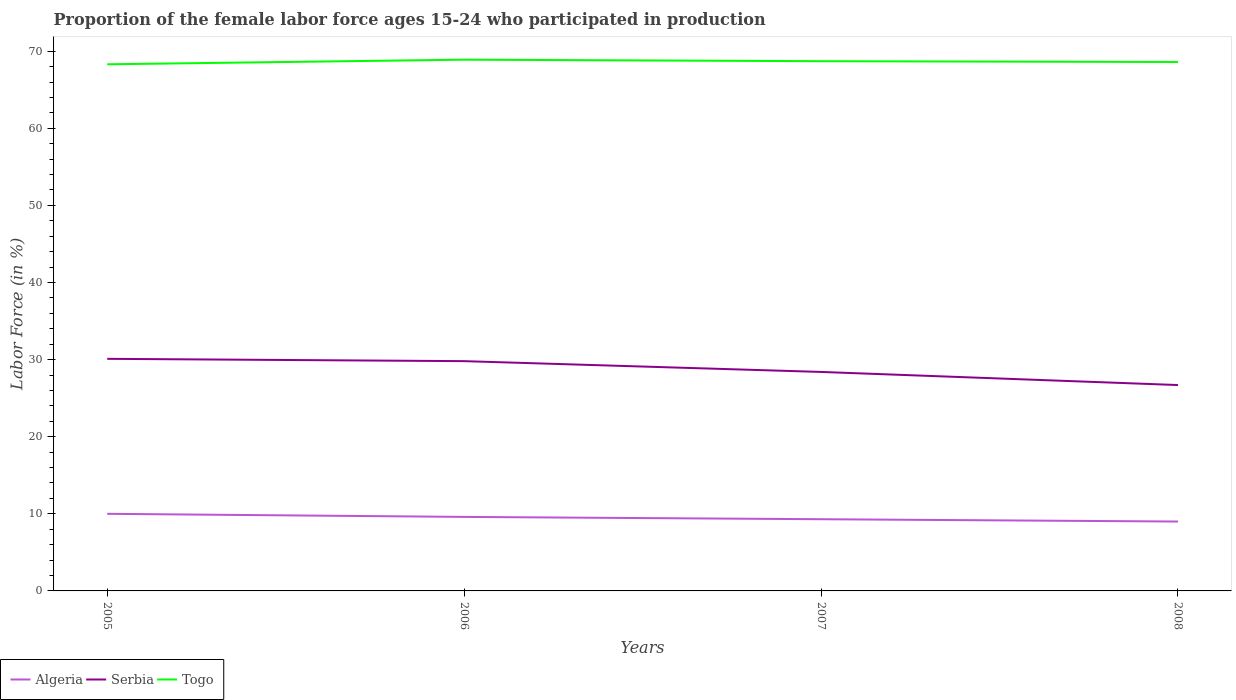How many different coloured lines are there?
Your response must be concise. 3. Does the line corresponding to Serbia intersect with the line corresponding to Togo?
Ensure brevity in your answer.  No. Is the number of lines equal to the number of legend labels?
Make the answer very short. Yes. Across all years, what is the maximum proportion of the female labor force who participated in production in Serbia?
Provide a succinct answer. 26.7. In which year was the proportion of the female labor force who participated in production in Serbia maximum?
Make the answer very short. 2008. What is the total proportion of the female labor force who participated in production in Serbia in the graph?
Your answer should be very brief. 0.3. What is the difference between the highest and the second highest proportion of the female labor force who participated in production in Togo?
Your answer should be compact. 0.6. How many years are there in the graph?
Keep it short and to the point. 4. What is the difference between two consecutive major ticks on the Y-axis?
Your response must be concise. 10. Are the values on the major ticks of Y-axis written in scientific E-notation?
Your answer should be compact. No. Where does the legend appear in the graph?
Your response must be concise. Bottom left. How many legend labels are there?
Your answer should be compact. 3. What is the title of the graph?
Provide a succinct answer. Proportion of the female labor force ages 15-24 who participated in production. Does "Switzerland" appear as one of the legend labels in the graph?
Ensure brevity in your answer.  No. What is the label or title of the X-axis?
Your answer should be very brief. Years. What is the Labor Force (in %) in Algeria in 2005?
Provide a short and direct response. 10. What is the Labor Force (in %) in Serbia in 2005?
Provide a short and direct response. 30.1. What is the Labor Force (in %) in Togo in 2005?
Ensure brevity in your answer.  68.3. What is the Labor Force (in %) of Algeria in 2006?
Give a very brief answer. 9.6. What is the Labor Force (in %) in Serbia in 2006?
Your response must be concise. 29.8. What is the Labor Force (in %) of Togo in 2006?
Provide a succinct answer. 68.9. What is the Labor Force (in %) of Algeria in 2007?
Keep it short and to the point. 9.3. What is the Labor Force (in %) in Serbia in 2007?
Offer a terse response. 28.4. What is the Labor Force (in %) of Togo in 2007?
Your answer should be compact. 68.7. What is the Labor Force (in %) of Serbia in 2008?
Your response must be concise. 26.7. What is the Labor Force (in %) in Togo in 2008?
Your answer should be very brief. 68.6. Across all years, what is the maximum Labor Force (in %) of Algeria?
Ensure brevity in your answer.  10. Across all years, what is the maximum Labor Force (in %) of Serbia?
Your response must be concise. 30.1. Across all years, what is the maximum Labor Force (in %) of Togo?
Ensure brevity in your answer.  68.9. Across all years, what is the minimum Labor Force (in %) of Serbia?
Provide a short and direct response. 26.7. Across all years, what is the minimum Labor Force (in %) in Togo?
Your answer should be very brief. 68.3. What is the total Labor Force (in %) of Algeria in the graph?
Your answer should be compact. 37.9. What is the total Labor Force (in %) of Serbia in the graph?
Your answer should be very brief. 115. What is the total Labor Force (in %) of Togo in the graph?
Offer a terse response. 274.5. What is the difference between the Labor Force (in %) of Togo in 2005 and that in 2006?
Make the answer very short. -0.6. What is the difference between the Labor Force (in %) in Serbia in 2005 and that in 2008?
Your answer should be very brief. 3.4. What is the difference between the Labor Force (in %) of Algeria in 2006 and that in 2007?
Provide a succinct answer. 0.3. What is the difference between the Labor Force (in %) in Togo in 2006 and that in 2007?
Your answer should be very brief. 0.2. What is the difference between the Labor Force (in %) of Serbia in 2006 and that in 2008?
Ensure brevity in your answer.  3.1. What is the difference between the Labor Force (in %) of Togo in 2006 and that in 2008?
Ensure brevity in your answer.  0.3. What is the difference between the Labor Force (in %) in Algeria in 2005 and the Labor Force (in %) in Serbia in 2006?
Your response must be concise. -19.8. What is the difference between the Labor Force (in %) of Algeria in 2005 and the Labor Force (in %) of Togo in 2006?
Offer a terse response. -58.9. What is the difference between the Labor Force (in %) in Serbia in 2005 and the Labor Force (in %) in Togo in 2006?
Offer a terse response. -38.8. What is the difference between the Labor Force (in %) of Algeria in 2005 and the Labor Force (in %) of Serbia in 2007?
Offer a terse response. -18.4. What is the difference between the Labor Force (in %) in Algeria in 2005 and the Labor Force (in %) in Togo in 2007?
Offer a terse response. -58.7. What is the difference between the Labor Force (in %) in Serbia in 2005 and the Labor Force (in %) in Togo in 2007?
Offer a very short reply. -38.6. What is the difference between the Labor Force (in %) of Algeria in 2005 and the Labor Force (in %) of Serbia in 2008?
Ensure brevity in your answer.  -16.7. What is the difference between the Labor Force (in %) in Algeria in 2005 and the Labor Force (in %) in Togo in 2008?
Offer a very short reply. -58.6. What is the difference between the Labor Force (in %) in Serbia in 2005 and the Labor Force (in %) in Togo in 2008?
Keep it short and to the point. -38.5. What is the difference between the Labor Force (in %) in Algeria in 2006 and the Labor Force (in %) in Serbia in 2007?
Offer a terse response. -18.8. What is the difference between the Labor Force (in %) of Algeria in 2006 and the Labor Force (in %) of Togo in 2007?
Your response must be concise. -59.1. What is the difference between the Labor Force (in %) in Serbia in 2006 and the Labor Force (in %) in Togo in 2007?
Give a very brief answer. -38.9. What is the difference between the Labor Force (in %) in Algeria in 2006 and the Labor Force (in %) in Serbia in 2008?
Provide a succinct answer. -17.1. What is the difference between the Labor Force (in %) in Algeria in 2006 and the Labor Force (in %) in Togo in 2008?
Provide a succinct answer. -59. What is the difference between the Labor Force (in %) in Serbia in 2006 and the Labor Force (in %) in Togo in 2008?
Make the answer very short. -38.8. What is the difference between the Labor Force (in %) of Algeria in 2007 and the Labor Force (in %) of Serbia in 2008?
Your answer should be very brief. -17.4. What is the difference between the Labor Force (in %) in Algeria in 2007 and the Labor Force (in %) in Togo in 2008?
Give a very brief answer. -59.3. What is the difference between the Labor Force (in %) in Serbia in 2007 and the Labor Force (in %) in Togo in 2008?
Make the answer very short. -40.2. What is the average Labor Force (in %) in Algeria per year?
Make the answer very short. 9.47. What is the average Labor Force (in %) of Serbia per year?
Your answer should be very brief. 28.75. What is the average Labor Force (in %) of Togo per year?
Your answer should be very brief. 68.62. In the year 2005, what is the difference between the Labor Force (in %) of Algeria and Labor Force (in %) of Serbia?
Provide a short and direct response. -20.1. In the year 2005, what is the difference between the Labor Force (in %) in Algeria and Labor Force (in %) in Togo?
Provide a succinct answer. -58.3. In the year 2005, what is the difference between the Labor Force (in %) in Serbia and Labor Force (in %) in Togo?
Your answer should be very brief. -38.2. In the year 2006, what is the difference between the Labor Force (in %) of Algeria and Labor Force (in %) of Serbia?
Make the answer very short. -20.2. In the year 2006, what is the difference between the Labor Force (in %) in Algeria and Labor Force (in %) in Togo?
Your answer should be very brief. -59.3. In the year 2006, what is the difference between the Labor Force (in %) in Serbia and Labor Force (in %) in Togo?
Your response must be concise. -39.1. In the year 2007, what is the difference between the Labor Force (in %) in Algeria and Labor Force (in %) in Serbia?
Your answer should be very brief. -19.1. In the year 2007, what is the difference between the Labor Force (in %) in Algeria and Labor Force (in %) in Togo?
Provide a short and direct response. -59.4. In the year 2007, what is the difference between the Labor Force (in %) of Serbia and Labor Force (in %) of Togo?
Your answer should be very brief. -40.3. In the year 2008, what is the difference between the Labor Force (in %) of Algeria and Labor Force (in %) of Serbia?
Give a very brief answer. -17.7. In the year 2008, what is the difference between the Labor Force (in %) of Algeria and Labor Force (in %) of Togo?
Offer a terse response. -59.6. In the year 2008, what is the difference between the Labor Force (in %) in Serbia and Labor Force (in %) in Togo?
Give a very brief answer. -41.9. What is the ratio of the Labor Force (in %) of Algeria in 2005 to that in 2006?
Provide a short and direct response. 1.04. What is the ratio of the Labor Force (in %) in Togo in 2005 to that in 2006?
Offer a very short reply. 0.99. What is the ratio of the Labor Force (in %) of Algeria in 2005 to that in 2007?
Ensure brevity in your answer.  1.08. What is the ratio of the Labor Force (in %) in Serbia in 2005 to that in 2007?
Your response must be concise. 1.06. What is the ratio of the Labor Force (in %) in Serbia in 2005 to that in 2008?
Make the answer very short. 1.13. What is the ratio of the Labor Force (in %) in Togo in 2005 to that in 2008?
Ensure brevity in your answer.  1. What is the ratio of the Labor Force (in %) of Algeria in 2006 to that in 2007?
Offer a terse response. 1.03. What is the ratio of the Labor Force (in %) in Serbia in 2006 to that in 2007?
Your answer should be compact. 1.05. What is the ratio of the Labor Force (in %) in Togo in 2006 to that in 2007?
Offer a terse response. 1. What is the ratio of the Labor Force (in %) of Algeria in 2006 to that in 2008?
Give a very brief answer. 1.07. What is the ratio of the Labor Force (in %) in Serbia in 2006 to that in 2008?
Provide a short and direct response. 1.12. What is the ratio of the Labor Force (in %) in Togo in 2006 to that in 2008?
Offer a very short reply. 1. What is the ratio of the Labor Force (in %) in Algeria in 2007 to that in 2008?
Your answer should be compact. 1.03. What is the ratio of the Labor Force (in %) in Serbia in 2007 to that in 2008?
Keep it short and to the point. 1.06. What is the difference between the highest and the second highest Labor Force (in %) in Algeria?
Your response must be concise. 0.4. What is the difference between the highest and the second highest Labor Force (in %) of Serbia?
Keep it short and to the point. 0.3. What is the difference between the highest and the second highest Labor Force (in %) in Togo?
Ensure brevity in your answer.  0.2. What is the difference between the highest and the lowest Labor Force (in %) in Algeria?
Provide a succinct answer. 1. What is the difference between the highest and the lowest Labor Force (in %) in Serbia?
Offer a very short reply. 3.4. 